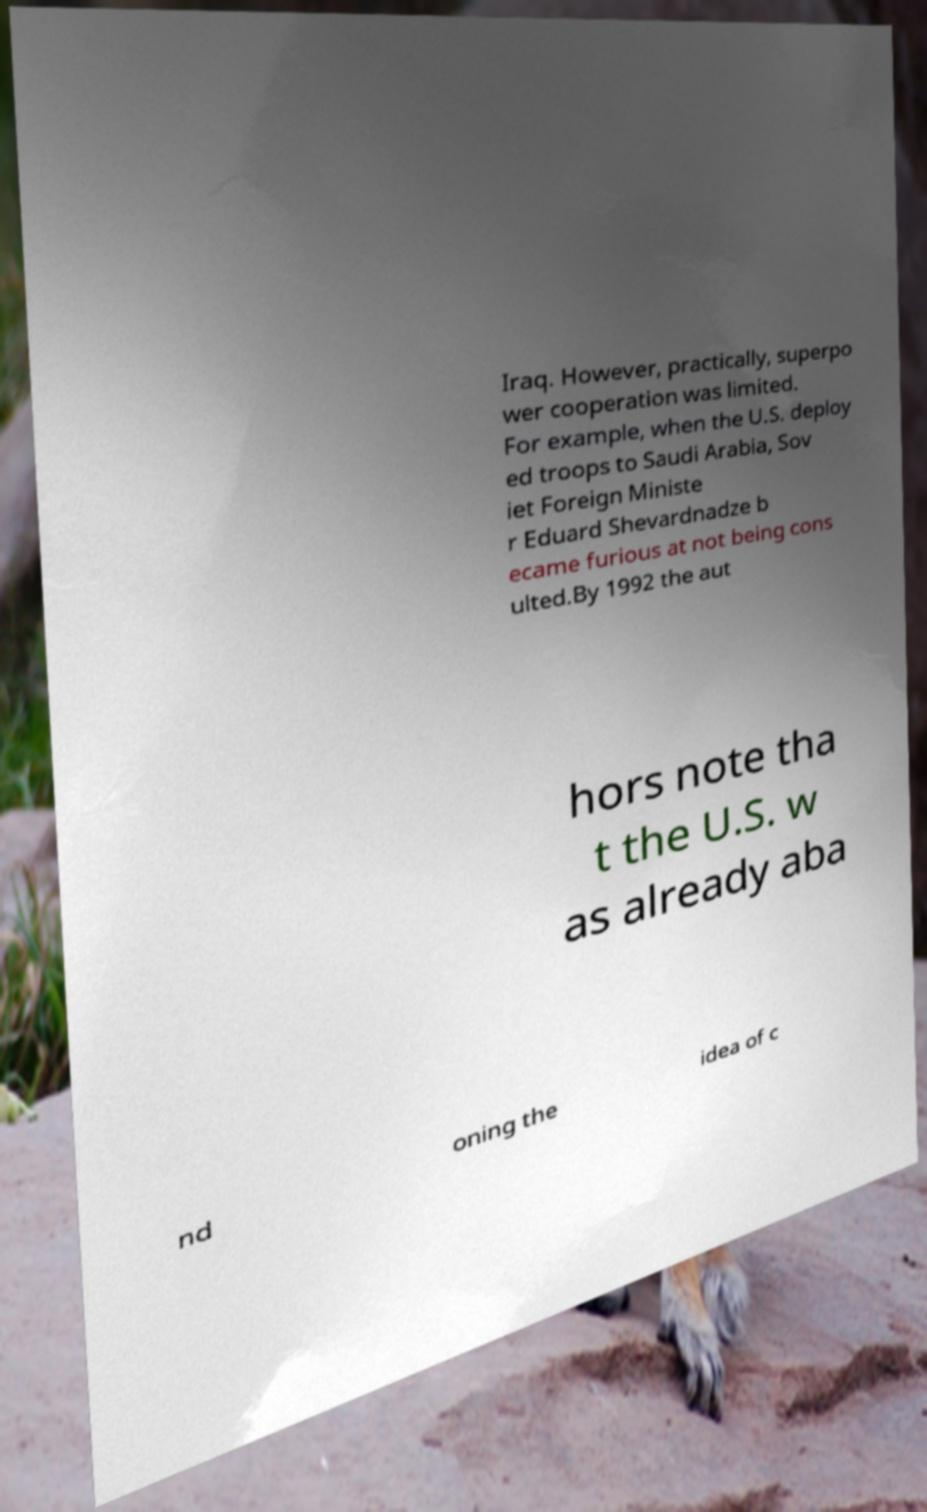Please identify and transcribe the text found in this image. Iraq. However, practically, superpo wer cooperation was limited. For example, when the U.S. deploy ed troops to Saudi Arabia, Sov iet Foreign Ministe r Eduard Shevardnadze b ecame furious at not being cons ulted.By 1992 the aut hors note tha t the U.S. w as already aba nd oning the idea of c 